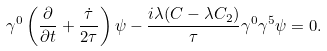<formula> <loc_0><loc_0><loc_500><loc_500>\gamma ^ { 0 } \left ( \frac { \partial } { \partial t } + \frac { \dot { \tau } } { 2 \tau } \right ) \psi - \frac { i \lambda ( C - \lambda C _ { 2 } ) } { \tau } \gamma ^ { 0 } \gamma ^ { 5 } \psi = 0 .</formula> 